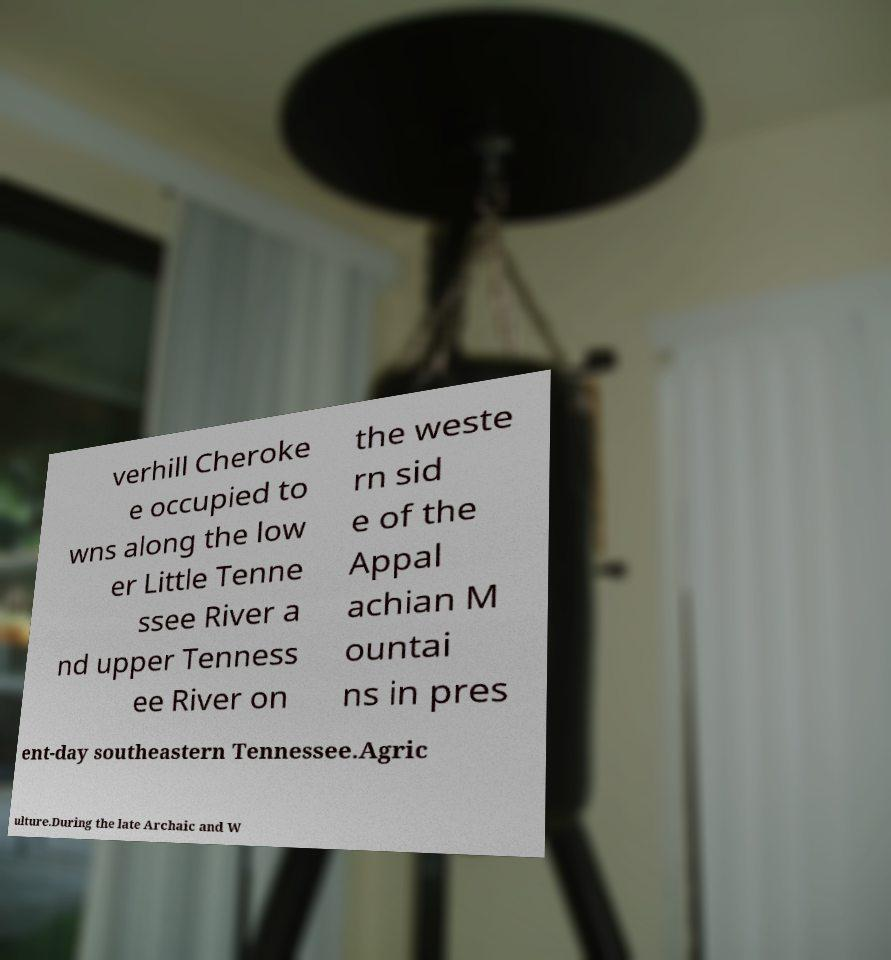For documentation purposes, I need the text within this image transcribed. Could you provide that? verhill Cheroke e occupied to wns along the low er Little Tenne ssee River a nd upper Tenness ee River on the weste rn sid e of the Appal achian M ountai ns in pres ent-day southeastern Tennessee.Agric ulture.During the late Archaic and W 